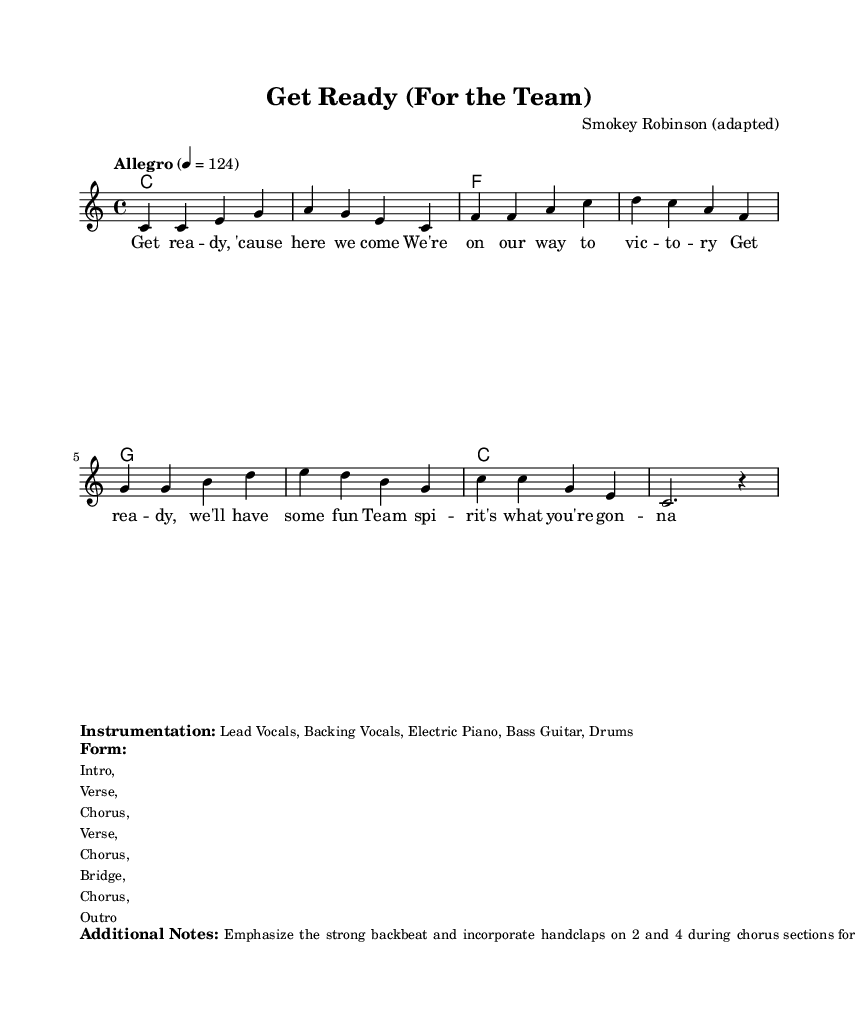What is the key signature of this music? The key signature is C major, which has no sharps or flats.
Answer: C major What is the time signature of this piece? The time signature is indicated at the beginning of the score as 4/4, meaning there are four beats in each measure.
Answer: 4/4 What is the tempo marking for this piece? The tempo marking is shown as "Allegro," which typically suggests a lively and brisk pace, followed by the specific speed of 124 beats per minute.
Answer: Allegro, 124 How many measures are in the verse section? The verse section comprises four measures of music, as indicated by the repeated lyrics. Counting the measures where the lyrics occur gives a total of four.
Answer: 4 In which section is handclapping emphasized? Handclapping is specifically mentioned to be emphasized during the chorus sections, indicating when to incorporate this action for added energy.
Answer: Chorus What instrumentation is used in this arrangement? The instrumentation includes Lead Vocals, Backing Vocals, Electric Piano, Bass Guitar, and Drums, as stated in the additional details of the score.
Answer: Lead Vocals, Backing Vocals, Electric Piano, Bass Guitar, Drums What rhythmic feature is emphasized in this piece? The strong backbeat is emphasized, specifically with handclaps occurring on beats 2 and 4, contributing to the overall energy of the piece.
Answer: Strong backbeat 